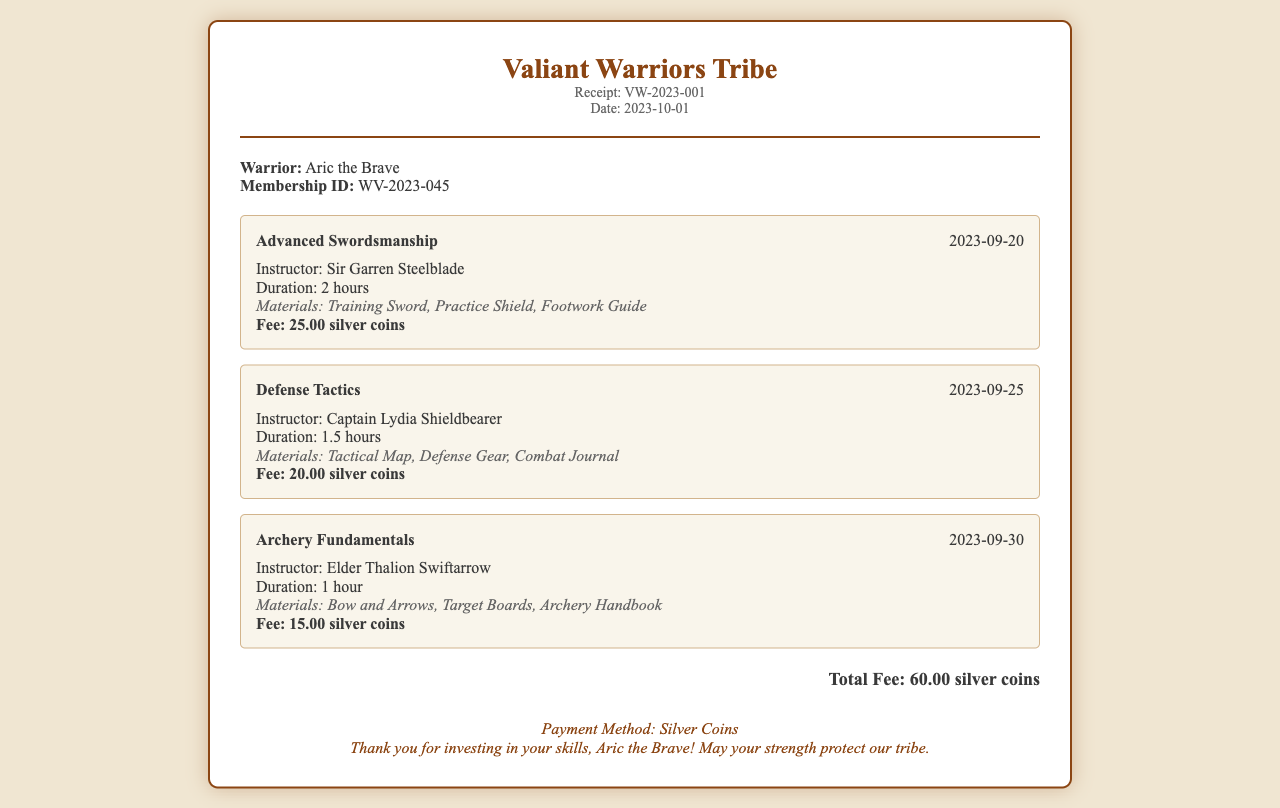What is the total fee? The total fee is listed at the bottom of the receipt, aggregating the fees for all sessions attended.
Answer: 60.00 silver coins Who is the warrior listed on the receipt? The warrior's name is mentioned at the top of the receipt under attendee info.
Answer: Aric the Brave What is the membership ID of the warrior? The membership ID is provided alongside the warrior's name in the attendee info section.
Answer: WV-2023-045 Who instructed the Archery Fundamentals session? The instructor's name for Archery Fundamentals is given in the session details.
Answer: Elder Thalion Swiftarrow What materials were used in the Defense Tactics session? The materials are listed in the session details for Defense Tactics.
Answer: Tactical Map, Defense Gear, Combat Journal How long was the Advanced Swordsmanship session? The duration is specified in hours within the session details.
Answer: 2 hours On what date did the Defense Tactics session occur? The date is provided in the session header for Defense Tactics.
Answer: 2023-09-25 What payment method is mentioned in the footer? The footer section of the receipt contains the information about the payment method.
Answer: Silver Coins How many instructors are mentioned in total in the receipt? This requires summing the different instructors listed in the session details.
Answer: 3 